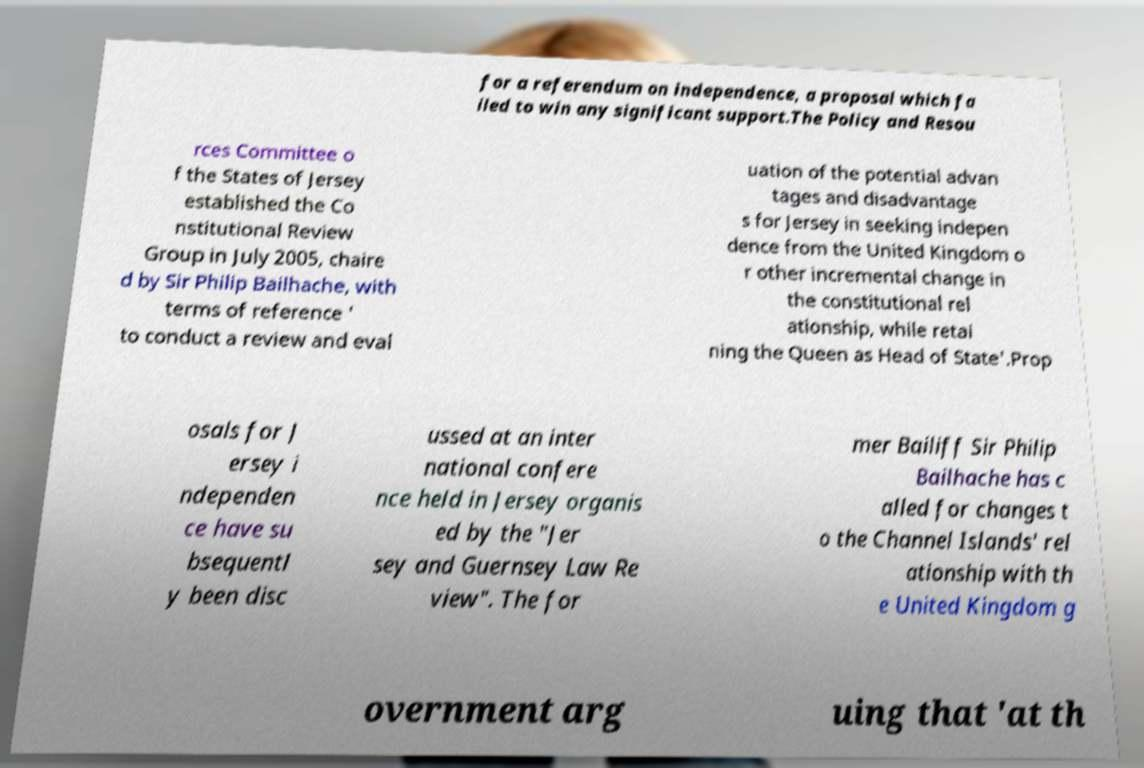For documentation purposes, I need the text within this image transcribed. Could you provide that? for a referendum on independence, a proposal which fa iled to win any significant support.The Policy and Resou rces Committee o f the States of Jersey established the Co nstitutional Review Group in July 2005, chaire d by Sir Philip Bailhache, with terms of reference ' to conduct a review and eval uation of the potential advan tages and disadvantage s for Jersey in seeking indepen dence from the United Kingdom o r other incremental change in the constitutional rel ationship, while retai ning the Queen as Head of State'.Prop osals for J ersey i ndependen ce have su bsequentl y been disc ussed at an inter national confere nce held in Jersey organis ed by the "Jer sey and Guernsey Law Re view". The for mer Bailiff Sir Philip Bailhache has c alled for changes t o the Channel Islands' rel ationship with th e United Kingdom g overnment arg uing that 'at th 